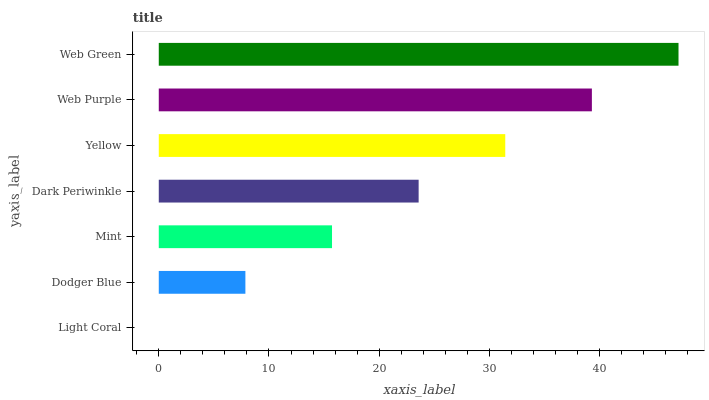Is Light Coral the minimum?
Answer yes or no. Yes. Is Web Green the maximum?
Answer yes or no. Yes. Is Dodger Blue the minimum?
Answer yes or no. No. Is Dodger Blue the maximum?
Answer yes or no. No. Is Dodger Blue greater than Light Coral?
Answer yes or no. Yes. Is Light Coral less than Dodger Blue?
Answer yes or no. Yes. Is Light Coral greater than Dodger Blue?
Answer yes or no. No. Is Dodger Blue less than Light Coral?
Answer yes or no. No. Is Dark Periwinkle the high median?
Answer yes or no. Yes. Is Dark Periwinkle the low median?
Answer yes or no. Yes. Is Web Purple the high median?
Answer yes or no. No. Is Yellow the low median?
Answer yes or no. No. 